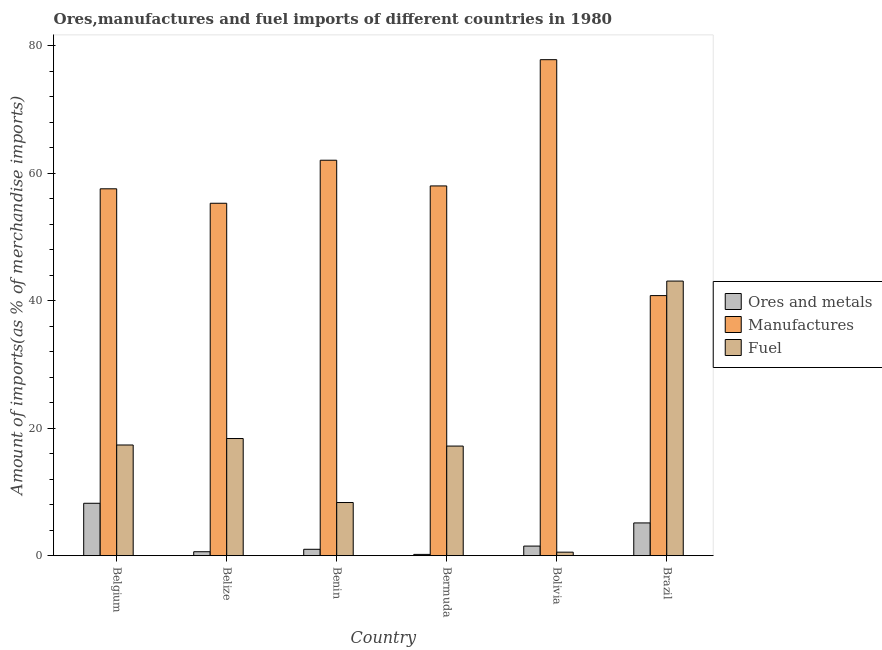Are the number of bars on each tick of the X-axis equal?
Provide a succinct answer. Yes. How many bars are there on the 1st tick from the left?
Offer a very short reply. 3. What is the percentage of manufactures imports in Belgium?
Provide a short and direct response. 57.56. Across all countries, what is the maximum percentage of manufactures imports?
Keep it short and to the point. 77.82. Across all countries, what is the minimum percentage of ores and metals imports?
Provide a short and direct response. 0.2. In which country was the percentage of manufactures imports maximum?
Offer a terse response. Bolivia. In which country was the percentage of manufactures imports minimum?
Offer a very short reply. Brazil. What is the total percentage of fuel imports in the graph?
Your response must be concise. 104.9. What is the difference between the percentage of manufactures imports in Benin and that in Bermuda?
Keep it short and to the point. 4.03. What is the difference between the percentage of fuel imports in Benin and the percentage of ores and metals imports in Belize?
Keep it short and to the point. 7.72. What is the average percentage of fuel imports per country?
Provide a succinct answer. 17.48. What is the difference between the percentage of fuel imports and percentage of ores and metals imports in Brazil?
Ensure brevity in your answer.  37.95. What is the ratio of the percentage of ores and metals imports in Belgium to that in Belize?
Provide a short and direct response. 13.33. Is the percentage of manufactures imports in Benin less than that in Bermuda?
Keep it short and to the point. No. Is the difference between the percentage of ores and metals imports in Belgium and Bermuda greater than the difference between the percentage of manufactures imports in Belgium and Bermuda?
Ensure brevity in your answer.  Yes. What is the difference between the highest and the second highest percentage of fuel imports?
Ensure brevity in your answer.  24.71. What is the difference between the highest and the lowest percentage of ores and metals imports?
Provide a succinct answer. 8.02. Is the sum of the percentage of manufactures imports in Belize and Bermuda greater than the maximum percentage of fuel imports across all countries?
Provide a succinct answer. Yes. What does the 2nd bar from the left in Belgium represents?
Give a very brief answer. Manufactures. What does the 2nd bar from the right in Bolivia represents?
Provide a succinct answer. Manufactures. How many bars are there?
Your answer should be very brief. 18. Are all the bars in the graph horizontal?
Provide a short and direct response. No. How many countries are there in the graph?
Offer a terse response. 6. Are the values on the major ticks of Y-axis written in scientific E-notation?
Offer a very short reply. No. Does the graph contain grids?
Keep it short and to the point. No. Where does the legend appear in the graph?
Make the answer very short. Center right. How are the legend labels stacked?
Give a very brief answer. Vertical. What is the title of the graph?
Offer a terse response. Ores,manufactures and fuel imports of different countries in 1980. Does "Social Protection and Labor" appear as one of the legend labels in the graph?
Provide a succinct answer. No. What is the label or title of the Y-axis?
Provide a short and direct response. Amount of imports(as % of merchandise imports). What is the Amount of imports(as % of merchandise imports) of Ores and metals in Belgium?
Give a very brief answer. 8.22. What is the Amount of imports(as % of merchandise imports) in Manufactures in Belgium?
Ensure brevity in your answer.  57.56. What is the Amount of imports(as % of merchandise imports) in Fuel in Belgium?
Make the answer very short. 17.36. What is the Amount of imports(as % of merchandise imports) of Ores and metals in Belize?
Provide a short and direct response. 0.62. What is the Amount of imports(as % of merchandise imports) in Manufactures in Belize?
Provide a succinct answer. 55.29. What is the Amount of imports(as % of merchandise imports) of Fuel in Belize?
Offer a terse response. 18.38. What is the Amount of imports(as % of merchandise imports) of Ores and metals in Benin?
Offer a terse response. 1. What is the Amount of imports(as % of merchandise imports) in Manufactures in Benin?
Keep it short and to the point. 62.05. What is the Amount of imports(as % of merchandise imports) in Fuel in Benin?
Make the answer very short. 8.34. What is the Amount of imports(as % of merchandise imports) of Ores and metals in Bermuda?
Offer a terse response. 0.2. What is the Amount of imports(as % of merchandise imports) of Manufactures in Bermuda?
Make the answer very short. 58.01. What is the Amount of imports(as % of merchandise imports) of Fuel in Bermuda?
Provide a succinct answer. 17.19. What is the Amount of imports(as % of merchandise imports) in Ores and metals in Bolivia?
Provide a short and direct response. 1.5. What is the Amount of imports(as % of merchandise imports) in Manufactures in Bolivia?
Provide a succinct answer. 77.82. What is the Amount of imports(as % of merchandise imports) of Fuel in Bolivia?
Give a very brief answer. 0.55. What is the Amount of imports(as % of merchandise imports) in Ores and metals in Brazil?
Make the answer very short. 5.14. What is the Amount of imports(as % of merchandise imports) of Manufactures in Brazil?
Your answer should be compact. 40.8. What is the Amount of imports(as % of merchandise imports) of Fuel in Brazil?
Provide a short and direct response. 43.08. Across all countries, what is the maximum Amount of imports(as % of merchandise imports) of Ores and metals?
Your answer should be very brief. 8.22. Across all countries, what is the maximum Amount of imports(as % of merchandise imports) of Manufactures?
Your response must be concise. 77.82. Across all countries, what is the maximum Amount of imports(as % of merchandise imports) of Fuel?
Your answer should be very brief. 43.08. Across all countries, what is the minimum Amount of imports(as % of merchandise imports) of Ores and metals?
Ensure brevity in your answer.  0.2. Across all countries, what is the minimum Amount of imports(as % of merchandise imports) of Manufactures?
Offer a terse response. 40.8. Across all countries, what is the minimum Amount of imports(as % of merchandise imports) of Fuel?
Your response must be concise. 0.55. What is the total Amount of imports(as % of merchandise imports) of Ores and metals in the graph?
Ensure brevity in your answer.  16.67. What is the total Amount of imports(as % of merchandise imports) in Manufactures in the graph?
Provide a succinct answer. 351.54. What is the total Amount of imports(as % of merchandise imports) of Fuel in the graph?
Make the answer very short. 104.9. What is the difference between the Amount of imports(as % of merchandise imports) of Ores and metals in Belgium and that in Belize?
Offer a very short reply. 7.6. What is the difference between the Amount of imports(as % of merchandise imports) in Manufactures in Belgium and that in Belize?
Keep it short and to the point. 2.27. What is the difference between the Amount of imports(as % of merchandise imports) of Fuel in Belgium and that in Belize?
Provide a short and direct response. -1.02. What is the difference between the Amount of imports(as % of merchandise imports) of Ores and metals in Belgium and that in Benin?
Your answer should be very brief. 7.22. What is the difference between the Amount of imports(as % of merchandise imports) of Manufactures in Belgium and that in Benin?
Offer a terse response. -4.48. What is the difference between the Amount of imports(as % of merchandise imports) in Fuel in Belgium and that in Benin?
Offer a very short reply. 9.03. What is the difference between the Amount of imports(as % of merchandise imports) in Ores and metals in Belgium and that in Bermuda?
Offer a terse response. 8.02. What is the difference between the Amount of imports(as % of merchandise imports) in Manufactures in Belgium and that in Bermuda?
Give a very brief answer. -0.45. What is the difference between the Amount of imports(as % of merchandise imports) in Fuel in Belgium and that in Bermuda?
Your response must be concise. 0.17. What is the difference between the Amount of imports(as % of merchandise imports) of Ores and metals in Belgium and that in Bolivia?
Offer a very short reply. 6.72. What is the difference between the Amount of imports(as % of merchandise imports) in Manufactures in Belgium and that in Bolivia?
Provide a short and direct response. -20.26. What is the difference between the Amount of imports(as % of merchandise imports) in Fuel in Belgium and that in Bolivia?
Provide a short and direct response. 16.82. What is the difference between the Amount of imports(as % of merchandise imports) in Ores and metals in Belgium and that in Brazil?
Offer a very short reply. 3.08. What is the difference between the Amount of imports(as % of merchandise imports) in Manufactures in Belgium and that in Brazil?
Keep it short and to the point. 16.76. What is the difference between the Amount of imports(as % of merchandise imports) in Fuel in Belgium and that in Brazil?
Give a very brief answer. -25.72. What is the difference between the Amount of imports(as % of merchandise imports) in Ores and metals in Belize and that in Benin?
Your answer should be compact. -0.38. What is the difference between the Amount of imports(as % of merchandise imports) of Manufactures in Belize and that in Benin?
Offer a very short reply. -6.75. What is the difference between the Amount of imports(as % of merchandise imports) in Fuel in Belize and that in Benin?
Provide a short and direct response. 10.04. What is the difference between the Amount of imports(as % of merchandise imports) in Ores and metals in Belize and that in Bermuda?
Make the answer very short. 0.42. What is the difference between the Amount of imports(as % of merchandise imports) of Manufactures in Belize and that in Bermuda?
Keep it short and to the point. -2.72. What is the difference between the Amount of imports(as % of merchandise imports) of Fuel in Belize and that in Bermuda?
Provide a succinct answer. 1.18. What is the difference between the Amount of imports(as % of merchandise imports) in Ores and metals in Belize and that in Bolivia?
Give a very brief answer. -0.88. What is the difference between the Amount of imports(as % of merchandise imports) of Manufactures in Belize and that in Bolivia?
Your answer should be very brief. -22.53. What is the difference between the Amount of imports(as % of merchandise imports) of Fuel in Belize and that in Bolivia?
Offer a very short reply. 17.83. What is the difference between the Amount of imports(as % of merchandise imports) in Ores and metals in Belize and that in Brazil?
Make the answer very short. -4.52. What is the difference between the Amount of imports(as % of merchandise imports) in Manufactures in Belize and that in Brazil?
Provide a succinct answer. 14.49. What is the difference between the Amount of imports(as % of merchandise imports) in Fuel in Belize and that in Brazil?
Ensure brevity in your answer.  -24.71. What is the difference between the Amount of imports(as % of merchandise imports) of Ores and metals in Benin and that in Bermuda?
Make the answer very short. 0.8. What is the difference between the Amount of imports(as % of merchandise imports) in Manufactures in Benin and that in Bermuda?
Keep it short and to the point. 4.03. What is the difference between the Amount of imports(as % of merchandise imports) of Fuel in Benin and that in Bermuda?
Make the answer very short. -8.86. What is the difference between the Amount of imports(as % of merchandise imports) in Ores and metals in Benin and that in Bolivia?
Your response must be concise. -0.5. What is the difference between the Amount of imports(as % of merchandise imports) of Manufactures in Benin and that in Bolivia?
Offer a very short reply. -15.78. What is the difference between the Amount of imports(as % of merchandise imports) in Fuel in Benin and that in Bolivia?
Provide a short and direct response. 7.79. What is the difference between the Amount of imports(as % of merchandise imports) of Ores and metals in Benin and that in Brazil?
Provide a succinct answer. -4.14. What is the difference between the Amount of imports(as % of merchandise imports) of Manufactures in Benin and that in Brazil?
Keep it short and to the point. 21.24. What is the difference between the Amount of imports(as % of merchandise imports) of Fuel in Benin and that in Brazil?
Offer a terse response. -34.75. What is the difference between the Amount of imports(as % of merchandise imports) in Ores and metals in Bermuda and that in Bolivia?
Make the answer very short. -1.3. What is the difference between the Amount of imports(as % of merchandise imports) of Manufactures in Bermuda and that in Bolivia?
Ensure brevity in your answer.  -19.81. What is the difference between the Amount of imports(as % of merchandise imports) of Fuel in Bermuda and that in Bolivia?
Provide a succinct answer. 16.65. What is the difference between the Amount of imports(as % of merchandise imports) in Ores and metals in Bermuda and that in Brazil?
Keep it short and to the point. -4.94. What is the difference between the Amount of imports(as % of merchandise imports) of Manufactures in Bermuda and that in Brazil?
Ensure brevity in your answer.  17.21. What is the difference between the Amount of imports(as % of merchandise imports) in Fuel in Bermuda and that in Brazil?
Offer a terse response. -25.89. What is the difference between the Amount of imports(as % of merchandise imports) of Ores and metals in Bolivia and that in Brazil?
Keep it short and to the point. -3.63. What is the difference between the Amount of imports(as % of merchandise imports) in Manufactures in Bolivia and that in Brazil?
Your answer should be compact. 37.02. What is the difference between the Amount of imports(as % of merchandise imports) of Fuel in Bolivia and that in Brazil?
Make the answer very short. -42.54. What is the difference between the Amount of imports(as % of merchandise imports) of Ores and metals in Belgium and the Amount of imports(as % of merchandise imports) of Manufactures in Belize?
Keep it short and to the point. -47.07. What is the difference between the Amount of imports(as % of merchandise imports) of Ores and metals in Belgium and the Amount of imports(as % of merchandise imports) of Fuel in Belize?
Your answer should be very brief. -10.16. What is the difference between the Amount of imports(as % of merchandise imports) in Manufactures in Belgium and the Amount of imports(as % of merchandise imports) in Fuel in Belize?
Your answer should be compact. 39.18. What is the difference between the Amount of imports(as % of merchandise imports) of Ores and metals in Belgium and the Amount of imports(as % of merchandise imports) of Manufactures in Benin?
Provide a short and direct response. -53.83. What is the difference between the Amount of imports(as % of merchandise imports) of Ores and metals in Belgium and the Amount of imports(as % of merchandise imports) of Fuel in Benin?
Provide a succinct answer. -0.12. What is the difference between the Amount of imports(as % of merchandise imports) of Manufactures in Belgium and the Amount of imports(as % of merchandise imports) of Fuel in Benin?
Offer a terse response. 49.23. What is the difference between the Amount of imports(as % of merchandise imports) of Ores and metals in Belgium and the Amount of imports(as % of merchandise imports) of Manufactures in Bermuda?
Provide a succinct answer. -49.79. What is the difference between the Amount of imports(as % of merchandise imports) in Ores and metals in Belgium and the Amount of imports(as % of merchandise imports) in Fuel in Bermuda?
Your answer should be compact. -8.98. What is the difference between the Amount of imports(as % of merchandise imports) of Manufactures in Belgium and the Amount of imports(as % of merchandise imports) of Fuel in Bermuda?
Keep it short and to the point. 40.37. What is the difference between the Amount of imports(as % of merchandise imports) of Ores and metals in Belgium and the Amount of imports(as % of merchandise imports) of Manufactures in Bolivia?
Keep it short and to the point. -69.6. What is the difference between the Amount of imports(as % of merchandise imports) in Ores and metals in Belgium and the Amount of imports(as % of merchandise imports) in Fuel in Bolivia?
Your response must be concise. 7.67. What is the difference between the Amount of imports(as % of merchandise imports) of Manufactures in Belgium and the Amount of imports(as % of merchandise imports) of Fuel in Bolivia?
Offer a terse response. 57.01. What is the difference between the Amount of imports(as % of merchandise imports) in Ores and metals in Belgium and the Amount of imports(as % of merchandise imports) in Manufactures in Brazil?
Provide a succinct answer. -32.59. What is the difference between the Amount of imports(as % of merchandise imports) in Ores and metals in Belgium and the Amount of imports(as % of merchandise imports) in Fuel in Brazil?
Your response must be concise. -34.87. What is the difference between the Amount of imports(as % of merchandise imports) in Manufactures in Belgium and the Amount of imports(as % of merchandise imports) in Fuel in Brazil?
Your response must be concise. 14.48. What is the difference between the Amount of imports(as % of merchandise imports) of Ores and metals in Belize and the Amount of imports(as % of merchandise imports) of Manufactures in Benin?
Ensure brevity in your answer.  -61.43. What is the difference between the Amount of imports(as % of merchandise imports) in Ores and metals in Belize and the Amount of imports(as % of merchandise imports) in Fuel in Benin?
Offer a very short reply. -7.72. What is the difference between the Amount of imports(as % of merchandise imports) of Manufactures in Belize and the Amount of imports(as % of merchandise imports) of Fuel in Benin?
Your answer should be compact. 46.96. What is the difference between the Amount of imports(as % of merchandise imports) in Ores and metals in Belize and the Amount of imports(as % of merchandise imports) in Manufactures in Bermuda?
Your answer should be compact. -57.4. What is the difference between the Amount of imports(as % of merchandise imports) of Ores and metals in Belize and the Amount of imports(as % of merchandise imports) of Fuel in Bermuda?
Ensure brevity in your answer.  -16.58. What is the difference between the Amount of imports(as % of merchandise imports) of Manufactures in Belize and the Amount of imports(as % of merchandise imports) of Fuel in Bermuda?
Keep it short and to the point. 38.1. What is the difference between the Amount of imports(as % of merchandise imports) of Ores and metals in Belize and the Amount of imports(as % of merchandise imports) of Manufactures in Bolivia?
Your answer should be compact. -77.21. What is the difference between the Amount of imports(as % of merchandise imports) of Ores and metals in Belize and the Amount of imports(as % of merchandise imports) of Fuel in Bolivia?
Your answer should be very brief. 0.07. What is the difference between the Amount of imports(as % of merchandise imports) in Manufactures in Belize and the Amount of imports(as % of merchandise imports) in Fuel in Bolivia?
Offer a terse response. 54.75. What is the difference between the Amount of imports(as % of merchandise imports) in Ores and metals in Belize and the Amount of imports(as % of merchandise imports) in Manufactures in Brazil?
Provide a short and direct response. -40.19. What is the difference between the Amount of imports(as % of merchandise imports) in Ores and metals in Belize and the Amount of imports(as % of merchandise imports) in Fuel in Brazil?
Offer a very short reply. -42.47. What is the difference between the Amount of imports(as % of merchandise imports) of Manufactures in Belize and the Amount of imports(as % of merchandise imports) of Fuel in Brazil?
Keep it short and to the point. 12.21. What is the difference between the Amount of imports(as % of merchandise imports) of Ores and metals in Benin and the Amount of imports(as % of merchandise imports) of Manufactures in Bermuda?
Give a very brief answer. -57.01. What is the difference between the Amount of imports(as % of merchandise imports) in Ores and metals in Benin and the Amount of imports(as % of merchandise imports) in Fuel in Bermuda?
Give a very brief answer. -16.2. What is the difference between the Amount of imports(as % of merchandise imports) in Manufactures in Benin and the Amount of imports(as % of merchandise imports) in Fuel in Bermuda?
Your answer should be very brief. 44.85. What is the difference between the Amount of imports(as % of merchandise imports) of Ores and metals in Benin and the Amount of imports(as % of merchandise imports) of Manufactures in Bolivia?
Provide a short and direct response. -76.82. What is the difference between the Amount of imports(as % of merchandise imports) in Ores and metals in Benin and the Amount of imports(as % of merchandise imports) in Fuel in Bolivia?
Provide a succinct answer. 0.45. What is the difference between the Amount of imports(as % of merchandise imports) in Manufactures in Benin and the Amount of imports(as % of merchandise imports) in Fuel in Bolivia?
Keep it short and to the point. 61.5. What is the difference between the Amount of imports(as % of merchandise imports) in Ores and metals in Benin and the Amount of imports(as % of merchandise imports) in Manufactures in Brazil?
Provide a succinct answer. -39.8. What is the difference between the Amount of imports(as % of merchandise imports) in Ores and metals in Benin and the Amount of imports(as % of merchandise imports) in Fuel in Brazil?
Your response must be concise. -42.09. What is the difference between the Amount of imports(as % of merchandise imports) in Manufactures in Benin and the Amount of imports(as % of merchandise imports) in Fuel in Brazil?
Your answer should be compact. 18.96. What is the difference between the Amount of imports(as % of merchandise imports) in Ores and metals in Bermuda and the Amount of imports(as % of merchandise imports) in Manufactures in Bolivia?
Your response must be concise. -77.62. What is the difference between the Amount of imports(as % of merchandise imports) in Ores and metals in Bermuda and the Amount of imports(as % of merchandise imports) in Fuel in Bolivia?
Make the answer very short. -0.35. What is the difference between the Amount of imports(as % of merchandise imports) in Manufactures in Bermuda and the Amount of imports(as % of merchandise imports) in Fuel in Bolivia?
Provide a short and direct response. 57.46. What is the difference between the Amount of imports(as % of merchandise imports) of Ores and metals in Bermuda and the Amount of imports(as % of merchandise imports) of Manufactures in Brazil?
Offer a terse response. -40.61. What is the difference between the Amount of imports(as % of merchandise imports) in Ores and metals in Bermuda and the Amount of imports(as % of merchandise imports) in Fuel in Brazil?
Keep it short and to the point. -42.89. What is the difference between the Amount of imports(as % of merchandise imports) of Manufactures in Bermuda and the Amount of imports(as % of merchandise imports) of Fuel in Brazil?
Your response must be concise. 14.93. What is the difference between the Amount of imports(as % of merchandise imports) in Ores and metals in Bolivia and the Amount of imports(as % of merchandise imports) in Manufactures in Brazil?
Offer a terse response. -39.3. What is the difference between the Amount of imports(as % of merchandise imports) in Ores and metals in Bolivia and the Amount of imports(as % of merchandise imports) in Fuel in Brazil?
Offer a terse response. -41.58. What is the difference between the Amount of imports(as % of merchandise imports) of Manufactures in Bolivia and the Amount of imports(as % of merchandise imports) of Fuel in Brazil?
Provide a succinct answer. 34.74. What is the average Amount of imports(as % of merchandise imports) in Ores and metals per country?
Keep it short and to the point. 2.78. What is the average Amount of imports(as % of merchandise imports) of Manufactures per country?
Offer a very short reply. 58.59. What is the average Amount of imports(as % of merchandise imports) of Fuel per country?
Your answer should be very brief. 17.48. What is the difference between the Amount of imports(as % of merchandise imports) in Ores and metals and Amount of imports(as % of merchandise imports) in Manufactures in Belgium?
Provide a succinct answer. -49.34. What is the difference between the Amount of imports(as % of merchandise imports) of Ores and metals and Amount of imports(as % of merchandise imports) of Fuel in Belgium?
Make the answer very short. -9.14. What is the difference between the Amount of imports(as % of merchandise imports) in Manufactures and Amount of imports(as % of merchandise imports) in Fuel in Belgium?
Make the answer very short. 40.2. What is the difference between the Amount of imports(as % of merchandise imports) in Ores and metals and Amount of imports(as % of merchandise imports) in Manufactures in Belize?
Provide a succinct answer. -54.68. What is the difference between the Amount of imports(as % of merchandise imports) of Ores and metals and Amount of imports(as % of merchandise imports) of Fuel in Belize?
Your answer should be very brief. -17.76. What is the difference between the Amount of imports(as % of merchandise imports) in Manufactures and Amount of imports(as % of merchandise imports) in Fuel in Belize?
Keep it short and to the point. 36.91. What is the difference between the Amount of imports(as % of merchandise imports) in Ores and metals and Amount of imports(as % of merchandise imports) in Manufactures in Benin?
Give a very brief answer. -61.05. What is the difference between the Amount of imports(as % of merchandise imports) in Ores and metals and Amount of imports(as % of merchandise imports) in Fuel in Benin?
Provide a short and direct response. -7.34. What is the difference between the Amount of imports(as % of merchandise imports) in Manufactures and Amount of imports(as % of merchandise imports) in Fuel in Benin?
Provide a succinct answer. 53.71. What is the difference between the Amount of imports(as % of merchandise imports) in Ores and metals and Amount of imports(as % of merchandise imports) in Manufactures in Bermuda?
Offer a very short reply. -57.81. What is the difference between the Amount of imports(as % of merchandise imports) of Ores and metals and Amount of imports(as % of merchandise imports) of Fuel in Bermuda?
Provide a short and direct response. -17. What is the difference between the Amount of imports(as % of merchandise imports) of Manufactures and Amount of imports(as % of merchandise imports) of Fuel in Bermuda?
Offer a terse response. 40.82. What is the difference between the Amount of imports(as % of merchandise imports) in Ores and metals and Amount of imports(as % of merchandise imports) in Manufactures in Bolivia?
Keep it short and to the point. -76.32. What is the difference between the Amount of imports(as % of merchandise imports) in Ores and metals and Amount of imports(as % of merchandise imports) in Fuel in Bolivia?
Ensure brevity in your answer.  0.95. What is the difference between the Amount of imports(as % of merchandise imports) of Manufactures and Amount of imports(as % of merchandise imports) of Fuel in Bolivia?
Your answer should be very brief. 77.27. What is the difference between the Amount of imports(as % of merchandise imports) of Ores and metals and Amount of imports(as % of merchandise imports) of Manufactures in Brazil?
Ensure brevity in your answer.  -35.67. What is the difference between the Amount of imports(as % of merchandise imports) in Ores and metals and Amount of imports(as % of merchandise imports) in Fuel in Brazil?
Your response must be concise. -37.95. What is the difference between the Amount of imports(as % of merchandise imports) in Manufactures and Amount of imports(as % of merchandise imports) in Fuel in Brazil?
Give a very brief answer. -2.28. What is the ratio of the Amount of imports(as % of merchandise imports) of Ores and metals in Belgium to that in Belize?
Ensure brevity in your answer.  13.33. What is the ratio of the Amount of imports(as % of merchandise imports) in Manufactures in Belgium to that in Belize?
Make the answer very short. 1.04. What is the ratio of the Amount of imports(as % of merchandise imports) of Fuel in Belgium to that in Belize?
Give a very brief answer. 0.94. What is the ratio of the Amount of imports(as % of merchandise imports) in Ores and metals in Belgium to that in Benin?
Ensure brevity in your answer.  8.23. What is the ratio of the Amount of imports(as % of merchandise imports) of Manufactures in Belgium to that in Benin?
Give a very brief answer. 0.93. What is the ratio of the Amount of imports(as % of merchandise imports) in Fuel in Belgium to that in Benin?
Offer a very short reply. 2.08. What is the ratio of the Amount of imports(as % of merchandise imports) of Ores and metals in Belgium to that in Bermuda?
Provide a short and direct response. 41.59. What is the ratio of the Amount of imports(as % of merchandise imports) in Manufactures in Belgium to that in Bermuda?
Give a very brief answer. 0.99. What is the ratio of the Amount of imports(as % of merchandise imports) in Fuel in Belgium to that in Bermuda?
Make the answer very short. 1.01. What is the ratio of the Amount of imports(as % of merchandise imports) in Ores and metals in Belgium to that in Bolivia?
Ensure brevity in your answer.  5.47. What is the ratio of the Amount of imports(as % of merchandise imports) of Manufactures in Belgium to that in Bolivia?
Your answer should be very brief. 0.74. What is the ratio of the Amount of imports(as % of merchandise imports) in Fuel in Belgium to that in Bolivia?
Your response must be concise. 31.72. What is the ratio of the Amount of imports(as % of merchandise imports) in Ores and metals in Belgium to that in Brazil?
Your answer should be compact. 1.6. What is the ratio of the Amount of imports(as % of merchandise imports) of Manufactures in Belgium to that in Brazil?
Make the answer very short. 1.41. What is the ratio of the Amount of imports(as % of merchandise imports) in Fuel in Belgium to that in Brazil?
Keep it short and to the point. 0.4. What is the ratio of the Amount of imports(as % of merchandise imports) of Ores and metals in Belize to that in Benin?
Keep it short and to the point. 0.62. What is the ratio of the Amount of imports(as % of merchandise imports) in Manufactures in Belize to that in Benin?
Provide a succinct answer. 0.89. What is the ratio of the Amount of imports(as % of merchandise imports) in Fuel in Belize to that in Benin?
Keep it short and to the point. 2.2. What is the ratio of the Amount of imports(as % of merchandise imports) in Ores and metals in Belize to that in Bermuda?
Provide a short and direct response. 3.12. What is the ratio of the Amount of imports(as % of merchandise imports) of Manufactures in Belize to that in Bermuda?
Ensure brevity in your answer.  0.95. What is the ratio of the Amount of imports(as % of merchandise imports) of Fuel in Belize to that in Bermuda?
Ensure brevity in your answer.  1.07. What is the ratio of the Amount of imports(as % of merchandise imports) in Ores and metals in Belize to that in Bolivia?
Your response must be concise. 0.41. What is the ratio of the Amount of imports(as % of merchandise imports) in Manufactures in Belize to that in Bolivia?
Offer a terse response. 0.71. What is the ratio of the Amount of imports(as % of merchandise imports) in Fuel in Belize to that in Bolivia?
Offer a terse response. 33.58. What is the ratio of the Amount of imports(as % of merchandise imports) of Ores and metals in Belize to that in Brazil?
Your response must be concise. 0.12. What is the ratio of the Amount of imports(as % of merchandise imports) in Manufactures in Belize to that in Brazil?
Offer a very short reply. 1.36. What is the ratio of the Amount of imports(as % of merchandise imports) of Fuel in Belize to that in Brazil?
Your answer should be very brief. 0.43. What is the ratio of the Amount of imports(as % of merchandise imports) in Ores and metals in Benin to that in Bermuda?
Your response must be concise. 5.05. What is the ratio of the Amount of imports(as % of merchandise imports) in Manufactures in Benin to that in Bermuda?
Your answer should be compact. 1.07. What is the ratio of the Amount of imports(as % of merchandise imports) in Fuel in Benin to that in Bermuda?
Ensure brevity in your answer.  0.48. What is the ratio of the Amount of imports(as % of merchandise imports) in Ores and metals in Benin to that in Bolivia?
Your answer should be very brief. 0.67. What is the ratio of the Amount of imports(as % of merchandise imports) in Manufactures in Benin to that in Bolivia?
Make the answer very short. 0.8. What is the ratio of the Amount of imports(as % of merchandise imports) of Fuel in Benin to that in Bolivia?
Make the answer very short. 15.23. What is the ratio of the Amount of imports(as % of merchandise imports) in Ores and metals in Benin to that in Brazil?
Give a very brief answer. 0.19. What is the ratio of the Amount of imports(as % of merchandise imports) in Manufactures in Benin to that in Brazil?
Provide a short and direct response. 1.52. What is the ratio of the Amount of imports(as % of merchandise imports) of Fuel in Benin to that in Brazil?
Your answer should be compact. 0.19. What is the ratio of the Amount of imports(as % of merchandise imports) in Ores and metals in Bermuda to that in Bolivia?
Offer a terse response. 0.13. What is the ratio of the Amount of imports(as % of merchandise imports) of Manufactures in Bermuda to that in Bolivia?
Your answer should be compact. 0.75. What is the ratio of the Amount of imports(as % of merchandise imports) in Fuel in Bermuda to that in Bolivia?
Keep it short and to the point. 31.41. What is the ratio of the Amount of imports(as % of merchandise imports) of Ores and metals in Bermuda to that in Brazil?
Offer a very short reply. 0.04. What is the ratio of the Amount of imports(as % of merchandise imports) in Manufactures in Bermuda to that in Brazil?
Offer a very short reply. 1.42. What is the ratio of the Amount of imports(as % of merchandise imports) in Fuel in Bermuda to that in Brazil?
Offer a terse response. 0.4. What is the ratio of the Amount of imports(as % of merchandise imports) of Ores and metals in Bolivia to that in Brazil?
Offer a terse response. 0.29. What is the ratio of the Amount of imports(as % of merchandise imports) in Manufactures in Bolivia to that in Brazil?
Ensure brevity in your answer.  1.91. What is the ratio of the Amount of imports(as % of merchandise imports) of Fuel in Bolivia to that in Brazil?
Your answer should be compact. 0.01. What is the difference between the highest and the second highest Amount of imports(as % of merchandise imports) in Ores and metals?
Give a very brief answer. 3.08. What is the difference between the highest and the second highest Amount of imports(as % of merchandise imports) in Manufactures?
Your response must be concise. 15.78. What is the difference between the highest and the second highest Amount of imports(as % of merchandise imports) in Fuel?
Provide a succinct answer. 24.71. What is the difference between the highest and the lowest Amount of imports(as % of merchandise imports) in Ores and metals?
Make the answer very short. 8.02. What is the difference between the highest and the lowest Amount of imports(as % of merchandise imports) in Manufactures?
Keep it short and to the point. 37.02. What is the difference between the highest and the lowest Amount of imports(as % of merchandise imports) of Fuel?
Your response must be concise. 42.54. 